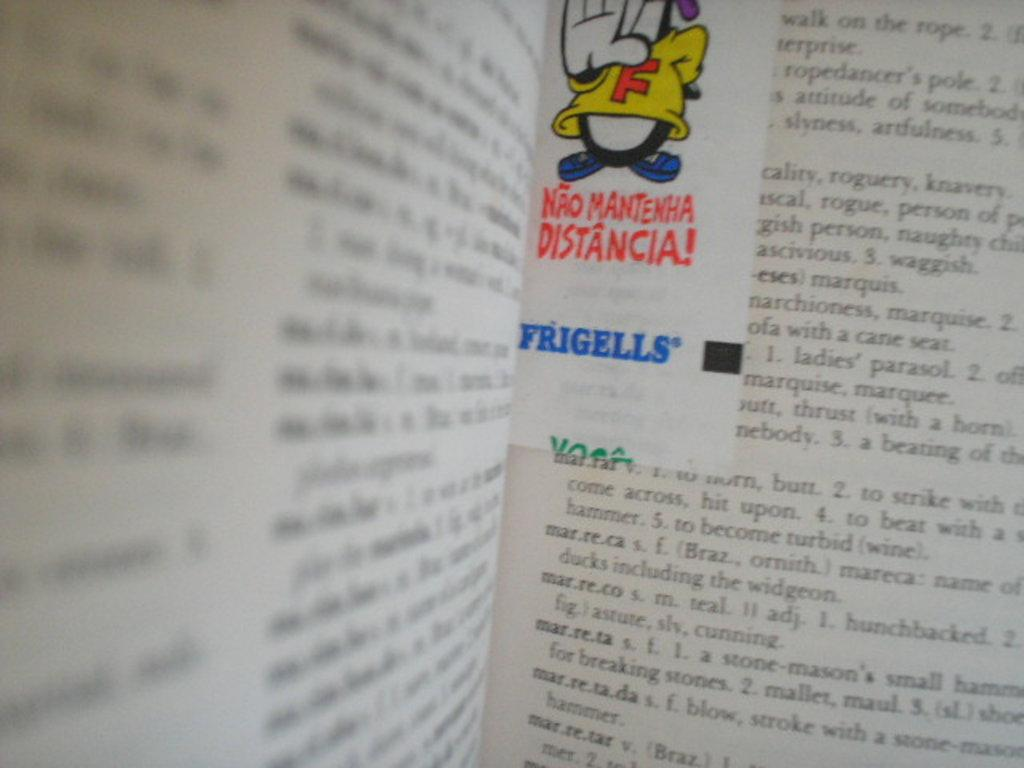<image>
Relay a brief, clear account of the picture shown. An open book with foreign text including the word Frigells. 